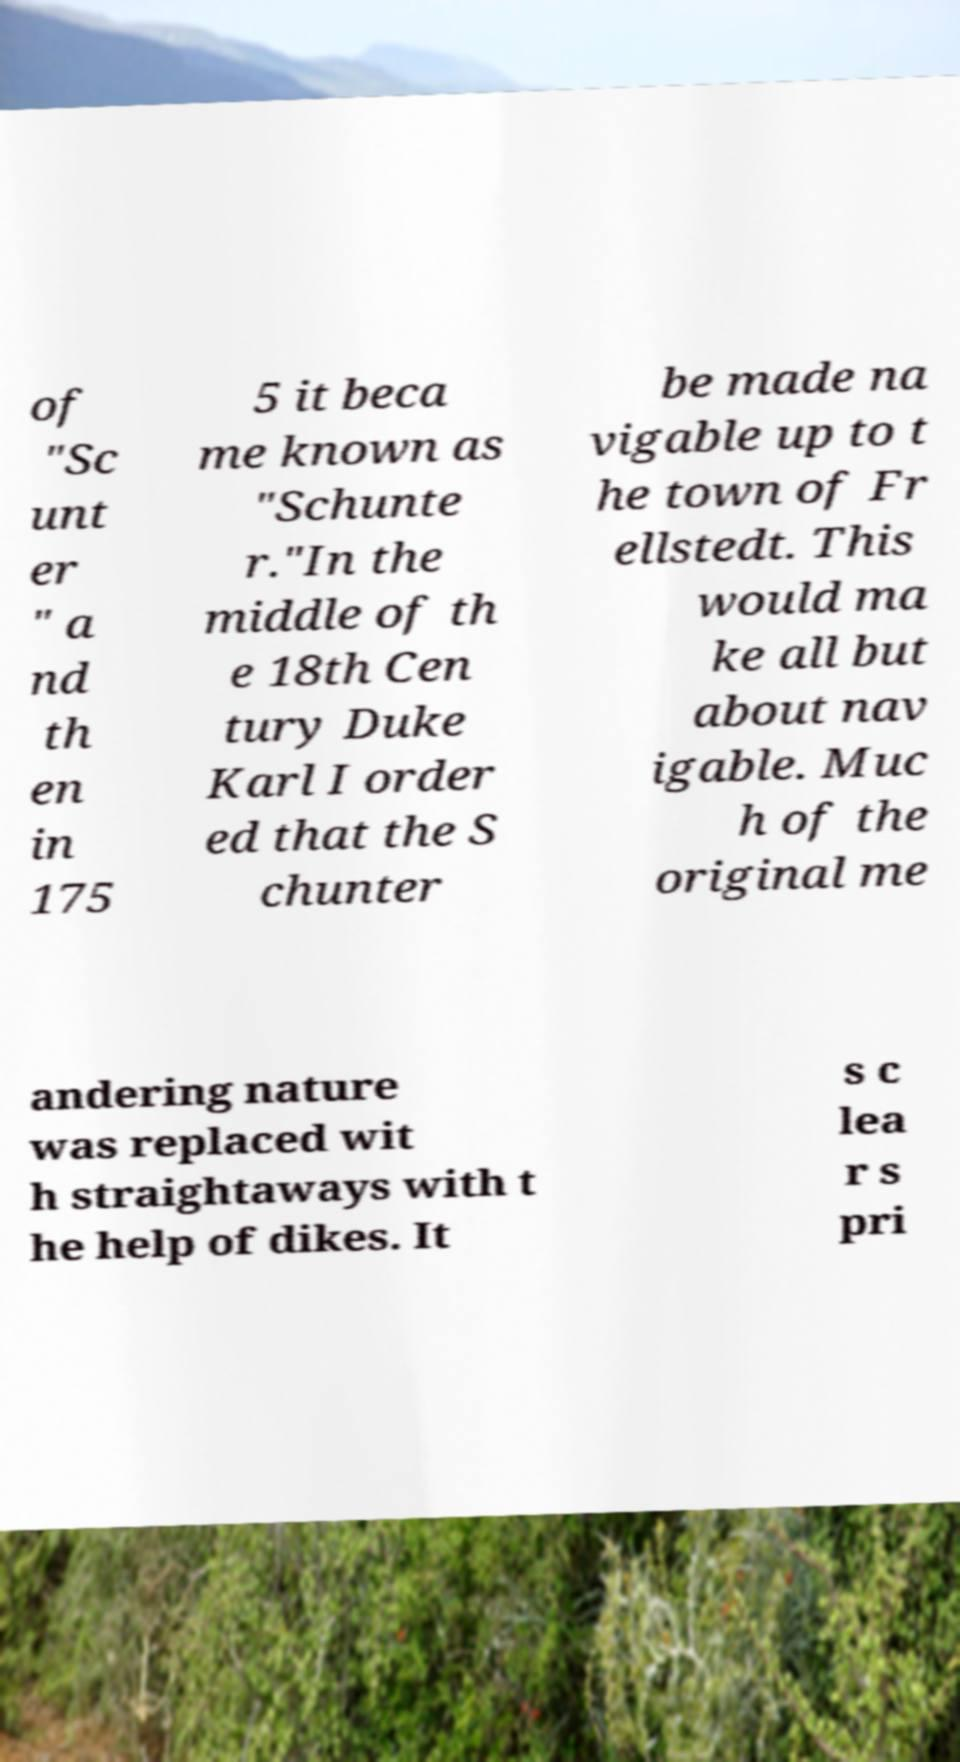Could you extract and type out the text from this image? of "Sc unt er " a nd th en in 175 5 it beca me known as "Schunte r."In the middle of th e 18th Cen tury Duke Karl I order ed that the S chunter be made na vigable up to t he town of Fr ellstedt. This would ma ke all but about nav igable. Muc h of the original me andering nature was replaced wit h straightaways with t he help of dikes. It s c lea r s pri 